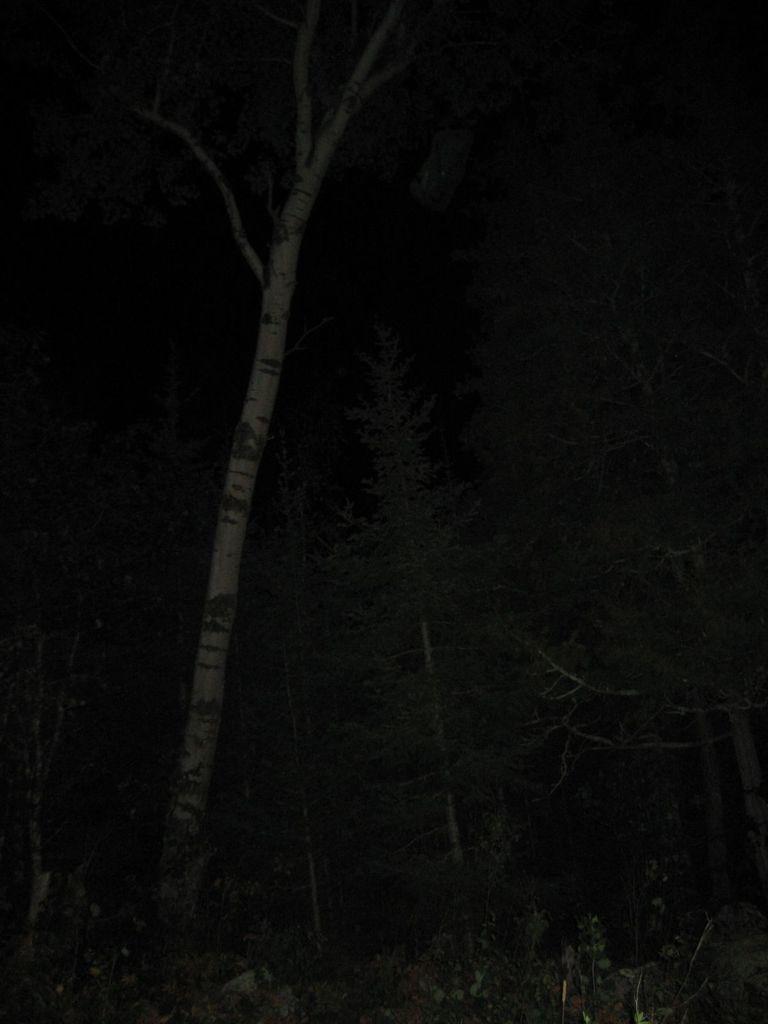Could you give a brief overview of what you see in this image? In this image we can see trees in the dark. 